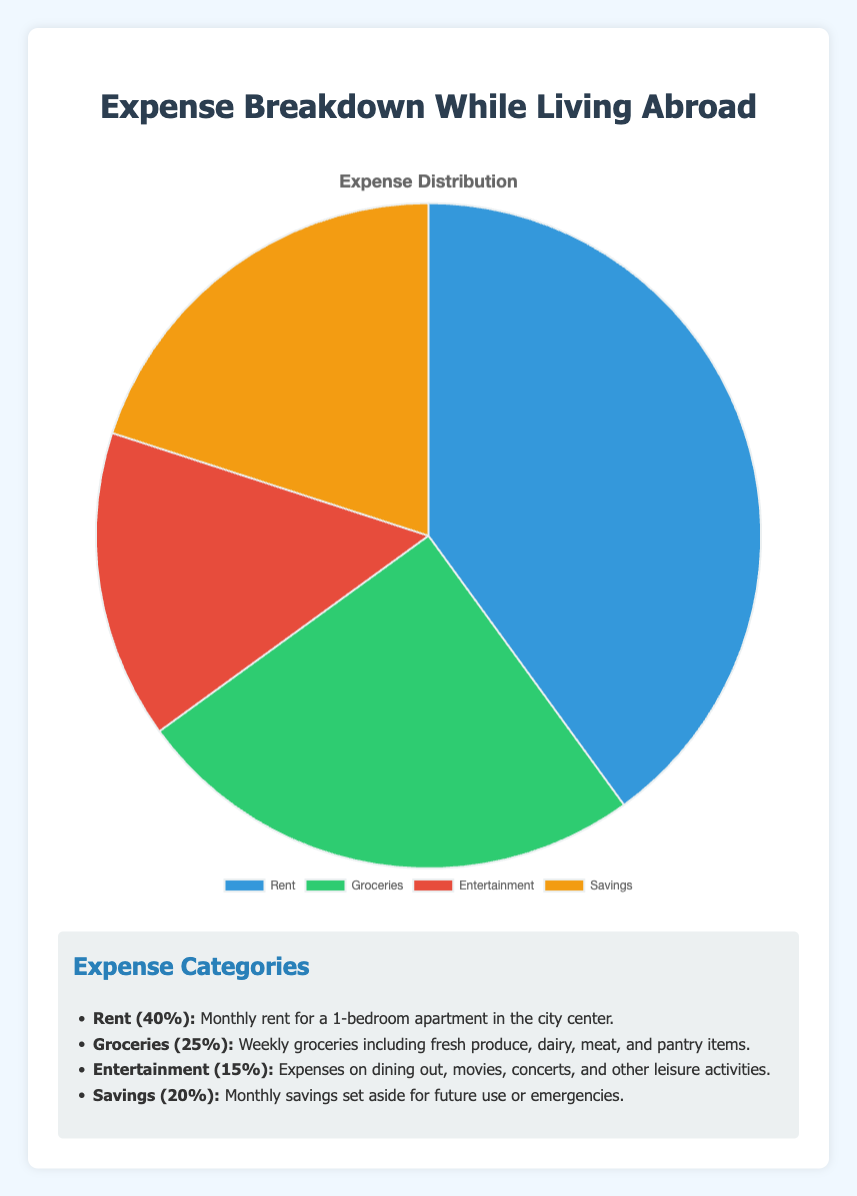What is the percentage of total expenses spent on Rent and Groceries combined? To find the combined percentage of expenses spent on Rent and Groceries, sum the percentages of these two categories. Rent takes up 40% and Groceries take up 25%. Therefore, the combined percentage is 40% + 25% = 65%.
Answer: 65% Which expense category has the lowest percentage and what is its value? To identify the expense category with the lowest percentage, we compare all the given percentage values. The categories are Rent (40%), Groceries (25%), Entertainment (15%), and Savings (20%). The lowest percentage is for Entertainment with 15%.
Answer: Entertainment, 15% By how many percentage points is Rent greater than Entertainment? The percentage spent on Rent is 40%, and the percentage spent on Entertainment is 15%. The difference is calculated by subtracting the Entertainment percentage from the Rent percentage. 40% - 15% = 25%.
Answer: 25 percentage points Does Groceries expense take up more or less than a quarter of the total expenses? A quarter of 100% total expenses is 25%. The Groceries category takes up exactly 25%, thus it takes up neither more nor less but exactly a quarter of the total expenses.
Answer: Exactly a quarter Rank the expense categories from highest to lowest percentage. To rank the categories, we need the percentage values for each category: Rent (40%), Groceries (25%), Savings (20%), Entertainment (15%). Arranging these in descending order: Rent, Groceries, Savings, Entertainment.
Answer: Rent, Groceries, Savings, Entertainment What fraction of the total expenses is dedicated to Savings? The percentage for Savings is 20%. To convert this to a fraction, divide 20 by 100 to get 20/100, which simplifies to 1/5. Thus, a fifth of the total expenses is dedicated to Savings.
Answer: 1/5 Which color represents the Savings category in the pie chart? The description provided indicates that colors used are '#3498db', '#2ecc71', '#e74c3c', and '#f39c12'. These correspond to blue, green, red, and yellow. Without colors visibly marked, we infer from standard order: considering the sequence Rent (blue), Groceries (green), Entertainment (red), Savings (yellow).
Answer: Yellow 